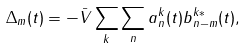<formula> <loc_0><loc_0><loc_500><loc_500>\Delta _ { m } ( t ) = - \bar { V } \sum _ { k } \sum _ { n } a ^ { k } _ { n } ( t ) b ^ { k * } _ { n - m } ( t ) ,</formula> 